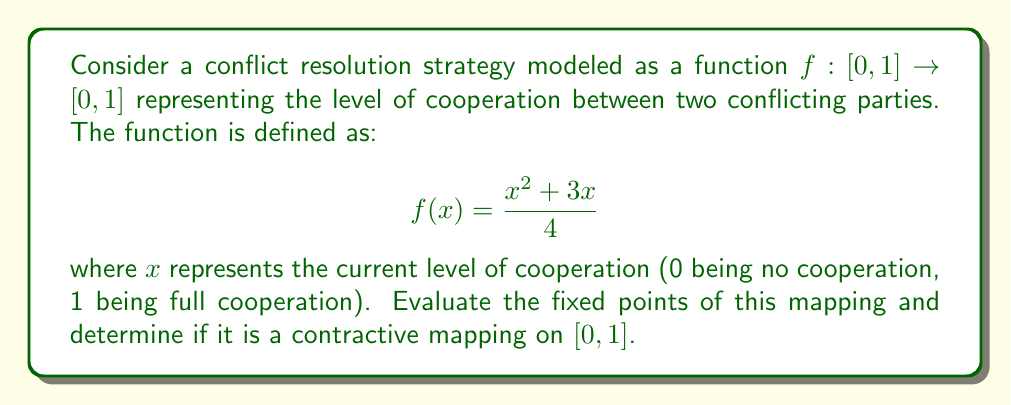Provide a solution to this math problem. To solve this problem, we'll follow these steps:

1. Find the fixed points of the function.
2. Determine if the mapping is contractive.

Step 1: Finding fixed points

Fixed points are values of $x$ where $f(x) = x$. We can find them by solving the equation:

$$x = \frac{x^2 + 3x}{4}$$

Multiply both sides by 4:

$$4x = x^2 + 3x$$

Rearrange terms:

$$x^2 - x = 0$$

Factor out $x$:

$$x(x - 1) = 0$$

The solutions are $x = 0$ and $x = 1$. These are the fixed points of the mapping.

Step 2: Determining if the mapping is contractive

A mapping is contractive if there exists a constant $k < 1$ such that for all $x, y$ in the domain:

$$|f(x) - f(y)| \leq k|x - y|$$

To check this, we can examine the derivative of $f(x)$:

$$f'(x) = \frac{2x + 3}{4}$$

On the interval $[0,1]$, the maximum value of $f'(x)$ occurs at $x = 1$:

$$f'(1) = \frac{5}{4} > 1$$

Since the derivative is greater than 1 at some point in the interval, the mapping is not contractive on $[0,1]$.

This result has implications for the stability of the conflict resolution strategy. The fact that the mapping is not contractive suggests that small changes in the initial conditions might lead to divergent outcomes, making the resolution process potentially unstable.
Answer: The fixed points of the mapping are $x = 0$ and $x = 1$. The mapping is not contractive on the interval $[0,1]$. 